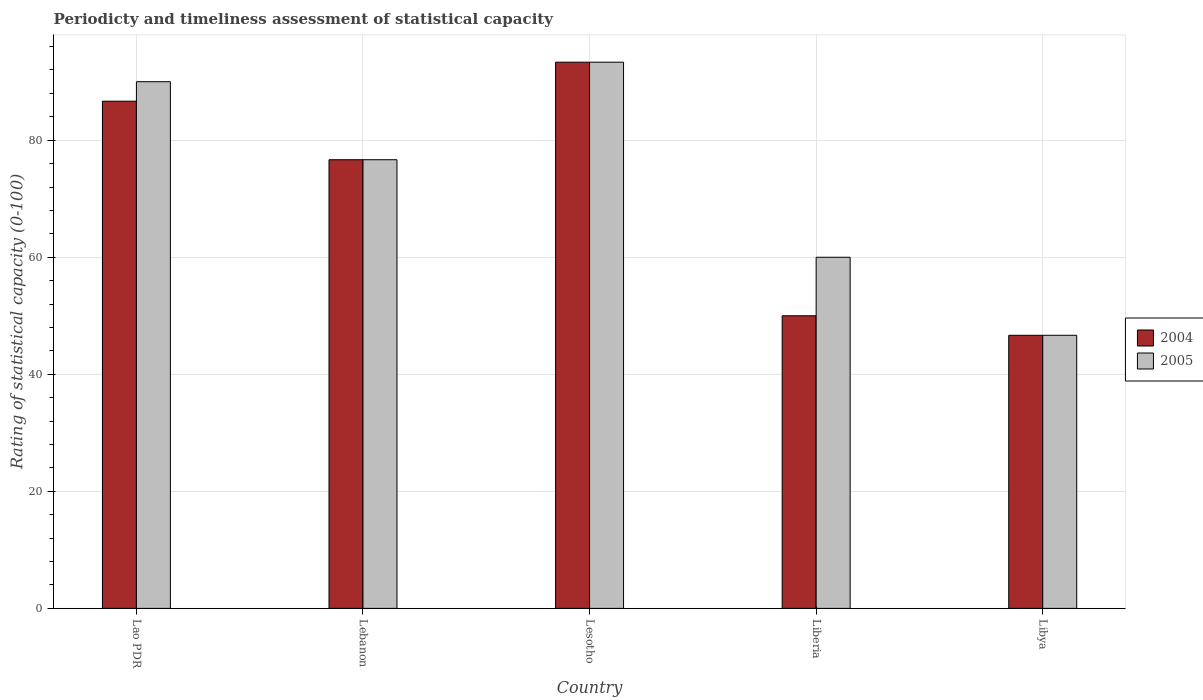How many different coloured bars are there?
Keep it short and to the point. 2. How many groups of bars are there?
Your response must be concise. 5. Are the number of bars per tick equal to the number of legend labels?
Keep it short and to the point. Yes. Are the number of bars on each tick of the X-axis equal?
Provide a succinct answer. Yes. What is the label of the 1st group of bars from the left?
Ensure brevity in your answer.  Lao PDR. In how many cases, is the number of bars for a given country not equal to the number of legend labels?
Provide a succinct answer. 0. What is the rating of statistical capacity in 2004 in Lao PDR?
Your response must be concise. 86.67. Across all countries, what is the maximum rating of statistical capacity in 2005?
Offer a terse response. 93.33. Across all countries, what is the minimum rating of statistical capacity in 2005?
Your answer should be very brief. 46.67. In which country was the rating of statistical capacity in 2005 maximum?
Provide a short and direct response. Lesotho. In which country was the rating of statistical capacity in 2004 minimum?
Ensure brevity in your answer.  Libya. What is the total rating of statistical capacity in 2005 in the graph?
Keep it short and to the point. 366.67. What is the difference between the rating of statistical capacity in 2005 in Lao PDR and that in Libya?
Make the answer very short. 43.33. What is the difference between the rating of statistical capacity in 2004 in Libya and the rating of statistical capacity in 2005 in Lesotho?
Offer a very short reply. -46.67. What is the average rating of statistical capacity in 2005 per country?
Provide a short and direct response. 73.33. What is the difference between the rating of statistical capacity of/in 2004 and rating of statistical capacity of/in 2005 in Lesotho?
Your response must be concise. 0. In how many countries, is the rating of statistical capacity in 2004 greater than 68?
Your answer should be very brief. 3. What is the ratio of the rating of statistical capacity in 2005 in Liberia to that in Libya?
Offer a very short reply. 1.29. Is the rating of statistical capacity in 2004 in Lebanon less than that in Liberia?
Ensure brevity in your answer.  No. What is the difference between the highest and the second highest rating of statistical capacity in 2004?
Your answer should be compact. -16.67. What is the difference between the highest and the lowest rating of statistical capacity in 2005?
Offer a terse response. 46.67. In how many countries, is the rating of statistical capacity in 2004 greater than the average rating of statistical capacity in 2004 taken over all countries?
Provide a succinct answer. 3. Is the sum of the rating of statistical capacity in 2004 in Lesotho and Libya greater than the maximum rating of statistical capacity in 2005 across all countries?
Make the answer very short. Yes. What does the 2nd bar from the right in Lao PDR represents?
Provide a short and direct response. 2004. Are all the bars in the graph horizontal?
Your response must be concise. No. Where does the legend appear in the graph?
Make the answer very short. Center right. How many legend labels are there?
Offer a very short reply. 2. How are the legend labels stacked?
Offer a terse response. Vertical. What is the title of the graph?
Provide a short and direct response. Periodicty and timeliness assessment of statistical capacity. What is the label or title of the Y-axis?
Your response must be concise. Rating of statistical capacity (0-100). What is the Rating of statistical capacity (0-100) in 2004 in Lao PDR?
Your answer should be compact. 86.67. What is the Rating of statistical capacity (0-100) of 2005 in Lao PDR?
Provide a succinct answer. 90. What is the Rating of statistical capacity (0-100) of 2004 in Lebanon?
Your response must be concise. 76.67. What is the Rating of statistical capacity (0-100) in 2005 in Lebanon?
Your answer should be very brief. 76.67. What is the Rating of statistical capacity (0-100) in 2004 in Lesotho?
Ensure brevity in your answer.  93.33. What is the Rating of statistical capacity (0-100) of 2005 in Lesotho?
Provide a succinct answer. 93.33. What is the Rating of statistical capacity (0-100) of 2004 in Liberia?
Make the answer very short. 50. What is the Rating of statistical capacity (0-100) in 2004 in Libya?
Your answer should be very brief. 46.67. What is the Rating of statistical capacity (0-100) of 2005 in Libya?
Offer a terse response. 46.67. Across all countries, what is the maximum Rating of statistical capacity (0-100) of 2004?
Your answer should be very brief. 93.33. Across all countries, what is the maximum Rating of statistical capacity (0-100) of 2005?
Offer a terse response. 93.33. Across all countries, what is the minimum Rating of statistical capacity (0-100) of 2004?
Your response must be concise. 46.67. Across all countries, what is the minimum Rating of statistical capacity (0-100) in 2005?
Provide a succinct answer. 46.67. What is the total Rating of statistical capacity (0-100) of 2004 in the graph?
Offer a very short reply. 353.33. What is the total Rating of statistical capacity (0-100) of 2005 in the graph?
Your answer should be very brief. 366.67. What is the difference between the Rating of statistical capacity (0-100) in 2004 in Lao PDR and that in Lebanon?
Your response must be concise. 10. What is the difference between the Rating of statistical capacity (0-100) in 2005 in Lao PDR and that in Lebanon?
Your answer should be very brief. 13.33. What is the difference between the Rating of statistical capacity (0-100) in 2004 in Lao PDR and that in Lesotho?
Offer a terse response. -6.67. What is the difference between the Rating of statistical capacity (0-100) in 2004 in Lao PDR and that in Liberia?
Provide a short and direct response. 36.67. What is the difference between the Rating of statistical capacity (0-100) in 2004 in Lao PDR and that in Libya?
Your answer should be very brief. 40. What is the difference between the Rating of statistical capacity (0-100) of 2005 in Lao PDR and that in Libya?
Your answer should be compact. 43.33. What is the difference between the Rating of statistical capacity (0-100) of 2004 in Lebanon and that in Lesotho?
Your response must be concise. -16.67. What is the difference between the Rating of statistical capacity (0-100) in 2005 in Lebanon and that in Lesotho?
Offer a terse response. -16.67. What is the difference between the Rating of statistical capacity (0-100) of 2004 in Lebanon and that in Liberia?
Give a very brief answer. 26.67. What is the difference between the Rating of statistical capacity (0-100) of 2005 in Lebanon and that in Liberia?
Provide a succinct answer. 16.67. What is the difference between the Rating of statistical capacity (0-100) in 2005 in Lebanon and that in Libya?
Ensure brevity in your answer.  30. What is the difference between the Rating of statistical capacity (0-100) of 2004 in Lesotho and that in Liberia?
Ensure brevity in your answer.  43.33. What is the difference between the Rating of statistical capacity (0-100) of 2005 in Lesotho and that in Liberia?
Your response must be concise. 33.33. What is the difference between the Rating of statistical capacity (0-100) in 2004 in Lesotho and that in Libya?
Give a very brief answer. 46.67. What is the difference between the Rating of statistical capacity (0-100) of 2005 in Lesotho and that in Libya?
Provide a short and direct response. 46.67. What is the difference between the Rating of statistical capacity (0-100) of 2004 in Liberia and that in Libya?
Keep it short and to the point. 3.33. What is the difference between the Rating of statistical capacity (0-100) of 2005 in Liberia and that in Libya?
Make the answer very short. 13.33. What is the difference between the Rating of statistical capacity (0-100) of 2004 in Lao PDR and the Rating of statistical capacity (0-100) of 2005 in Lebanon?
Provide a short and direct response. 10. What is the difference between the Rating of statistical capacity (0-100) in 2004 in Lao PDR and the Rating of statistical capacity (0-100) in 2005 in Lesotho?
Your answer should be compact. -6.67. What is the difference between the Rating of statistical capacity (0-100) in 2004 in Lao PDR and the Rating of statistical capacity (0-100) in 2005 in Liberia?
Offer a terse response. 26.67. What is the difference between the Rating of statistical capacity (0-100) of 2004 in Lebanon and the Rating of statistical capacity (0-100) of 2005 in Lesotho?
Make the answer very short. -16.67. What is the difference between the Rating of statistical capacity (0-100) of 2004 in Lebanon and the Rating of statistical capacity (0-100) of 2005 in Liberia?
Your response must be concise. 16.67. What is the difference between the Rating of statistical capacity (0-100) of 2004 in Lesotho and the Rating of statistical capacity (0-100) of 2005 in Liberia?
Provide a succinct answer. 33.33. What is the difference between the Rating of statistical capacity (0-100) in 2004 in Lesotho and the Rating of statistical capacity (0-100) in 2005 in Libya?
Make the answer very short. 46.67. What is the difference between the Rating of statistical capacity (0-100) in 2004 in Liberia and the Rating of statistical capacity (0-100) in 2005 in Libya?
Provide a succinct answer. 3.33. What is the average Rating of statistical capacity (0-100) of 2004 per country?
Ensure brevity in your answer.  70.67. What is the average Rating of statistical capacity (0-100) of 2005 per country?
Make the answer very short. 73.33. What is the difference between the Rating of statistical capacity (0-100) of 2004 and Rating of statistical capacity (0-100) of 2005 in Lao PDR?
Provide a short and direct response. -3.33. What is the ratio of the Rating of statistical capacity (0-100) of 2004 in Lao PDR to that in Lebanon?
Provide a short and direct response. 1.13. What is the ratio of the Rating of statistical capacity (0-100) in 2005 in Lao PDR to that in Lebanon?
Offer a very short reply. 1.17. What is the ratio of the Rating of statistical capacity (0-100) in 2004 in Lao PDR to that in Lesotho?
Offer a very short reply. 0.93. What is the ratio of the Rating of statistical capacity (0-100) in 2005 in Lao PDR to that in Lesotho?
Give a very brief answer. 0.96. What is the ratio of the Rating of statistical capacity (0-100) in 2004 in Lao PDR to that in Liberia?
Provide a short and direct response. 1.73. What is the ratio of the Rating of statistical capacity (0-100) in 2004 in Lao PDR to that in Libya?
Offer a very short reply. 1.86. What is the ratio of the Rating of statistical capacity (0-100) of 2005 in Lao PDR to that in Libya?
Provide a short and direct response. 1.93. What is the ratio of the Rating of statistical capacity (0-100) in 2004 in Lebanon to that in Lesotho?
Offer a very short reply. 0.82. What is the ratio of the Rating of statistical capacity (0-100) of 2005 in Lebanon to that in Lesotho?
Provide a short and direct response. 0.82. What is the ratio of the Rating of statistical capacity (0-100) in 2004 in Lebanon to that in Liberia?
Make the answer very short. 1.53. What is the ratio of the Rating of statistical capacity (0-100) in 2005 in Lebanon to that in Liberia?
Offer a very short reply. 1.28. What is the ratio of the Rating of statistical capacity (0-100) of 2004 in Lebanon to that in Libya?
Ensure brevity in your answer.  1.64. What is the ratio of the Rating of statistical capacity (0-100) in 2005 in Lebanon to that in Libya?
Ensure brevity in your answer.  1.64. What is the ratio of the Rating of statistical capacity (0-100) in 2004 in Lesotho to that in Liberia?
Give a very brief answer. 1.87. What is the ratio of the Rating of statistical capacity (0-100) of 2005 in Lesotho to that in Liberia?
Ensure brevity in your answer.  1.56. What is the ratio of the Rating of statistical capacity (0-100) of 2004 in Liberia to that in Libya?
Your answer should be very brief. 1.07. What is the ratio of the Rating of statistical capacity (0-100) in 2005 in Liberia to that in Libya?
Provide a short and direct response. 1.29. What is the difference between the highest and the lowest Rating of statistical capacity (0-100) of 2004?
Provide a short and direct response. 46.67. What is the difference between the highest and the lowest Rating of statistical capacity (0-100) of 2005?
Offer a very short reply. 46.67. 